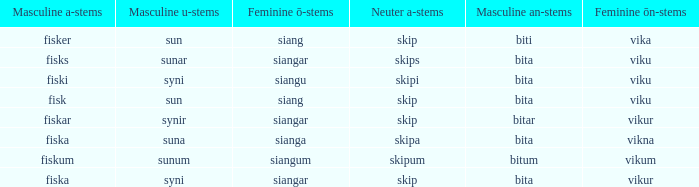What is the u-form of the word that has a neuter form of "skip" and a masculine a-ending of "fisker"? Sun. 